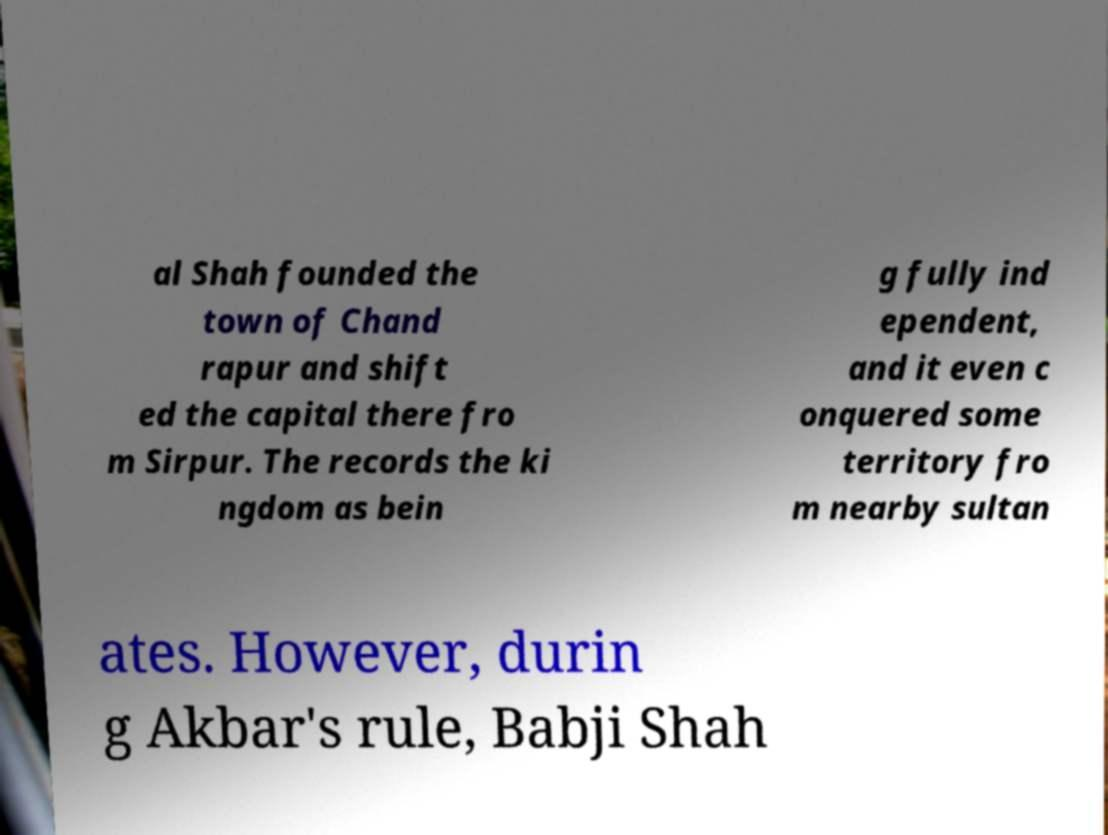What messages or text are displayed in this image? I need them in a readable, typed format. al Shah founded the town of Chand rapur and shift ed the capital there fro m Sirpur. The records the ki ngdom as bein g fully ind ependent, and it even c onquered some territory fro m nearby sultan ates. However, durin g Akbar's rule, Babji Shah 